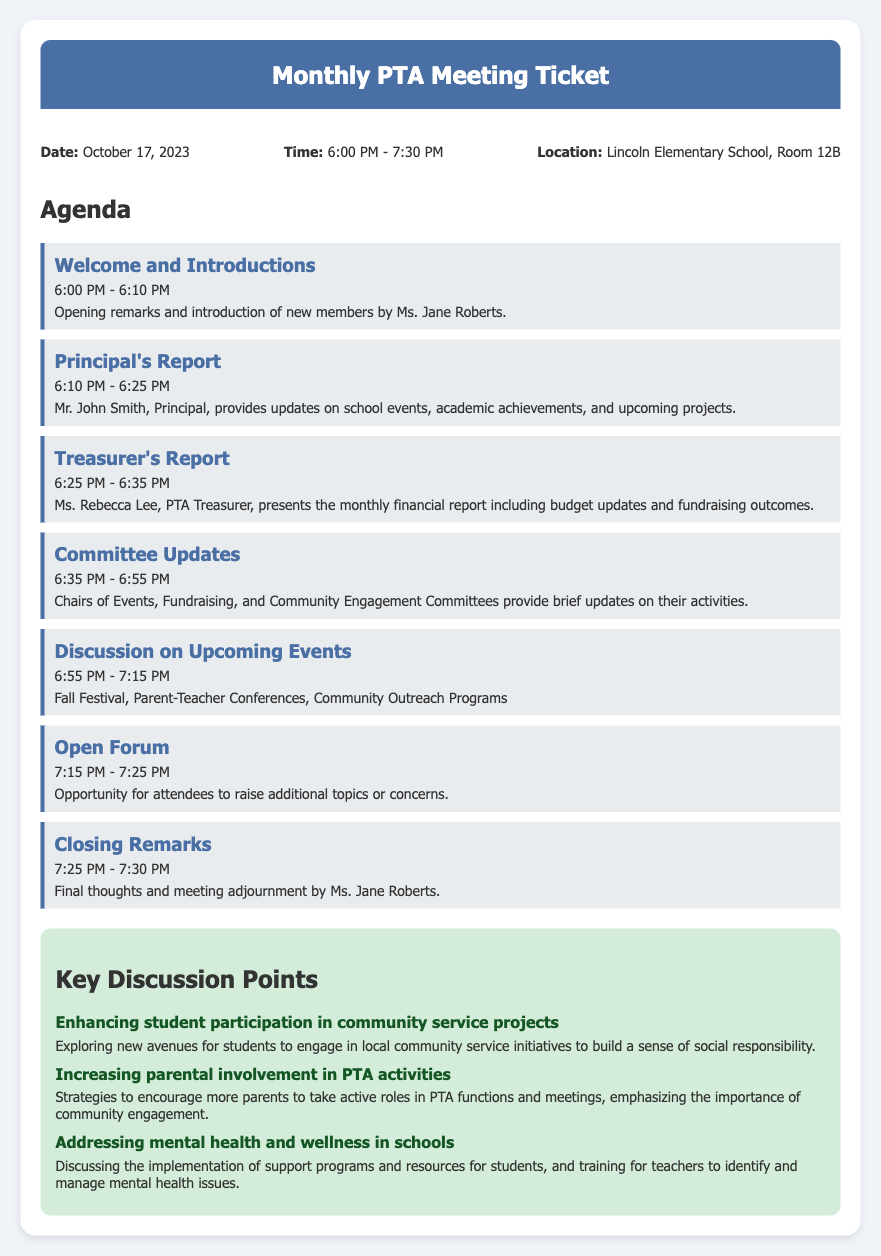What is the date of the meeting? The date of the meeting is mentioned in the document's information section.
Answer: October 17, 2023 What time does the meeting start? The starting time of the meeting is provided in the document.
Answer: 6:00 PM Who introduces the new members? The document specifies who will handle the welcome and introductions.
Answer: Ms. Jane Roberts What report does Mr. John Smith provide? The type of report given by the Principal is outlined in the agenda.
Answer: Principal's Report How long is the Committee Updates segment? The duration of the Committee Updates is noted in the agenda section.
Answer: 20 minutes What is one key discussion point about community service? The document lists key discussion points which include community service topics.
Answer: Enhancing student participation in community service projects What is discussed during the Open Forum? The agenda outlines the purpose of the Open Forum in the meeting.
Answer: Additional topics or concerns What is the main focus of the Treasurer's Report? The content of the Treasurer's Report is specified in the agenda.
Answer: Monthly financial report including budget updates and fundraising outcomes 